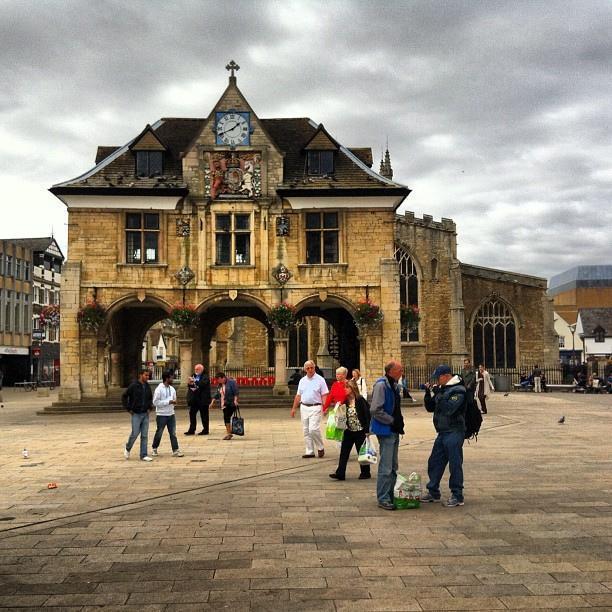How many arch walkways?
Give a very brief answer. 3. How many people are there?
Give a very brief answer. 3. 